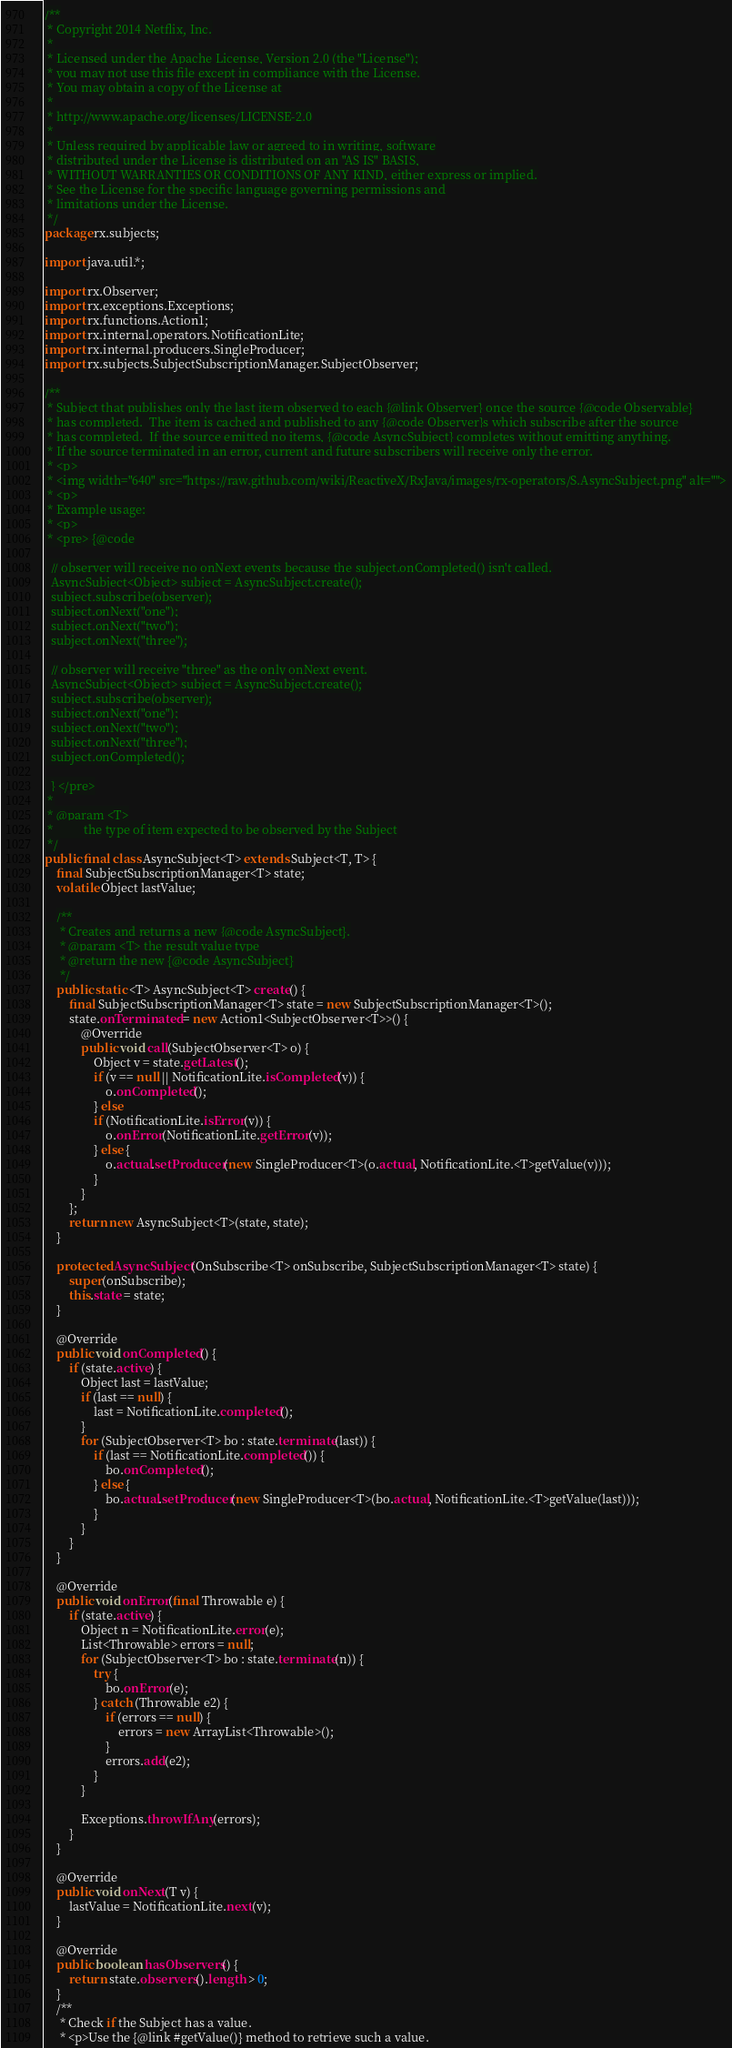<code> <loc_0><loc_0><loc_500><loc_500><_Java_>/**
 * Copyright 2014 Netflix, Inc.
 *
 * Licensed under the Apache License, Version 2.0 (the "License");
 * you may not use this file except in compliance with the License.
 * You may obtain a copy of the License at
 *
 * http://www.apache.org/licenses/LICENSE-2.0
 *
 * Unless required by applicable law or agreed to in writing, software
 * distributed under the License is distributed on an "AS IS" BASIS,
 * WITHOUT WARRANTIES OR CONDITIONS OF ANY KIND, either express or implied.
 * See the License for the specific language governing permissions and
 * limitations under the License.
 */
package rx.subjects;

import java.util.*;

import rx.Observer;
import rx.exceptions.Exceptions;
import rx.functions.Action1;
import rx.internal.operators.NotificationLite;
import rx.internal.producers.SingleProducer;
import rx.subjects.SubjectSubscriptionManager.SubjectObserver;

/**
 * Subject that publishes only the last item observed to each {@link Observer} once the source {@code Observable}
 * has completed.  The item is cached and published to any {@code Observer}s which subscribe after the source
 * has completed.  If the source emitted no items, {@code AsyncSubject} completes without emitting anything.
 * If the source terminated in an error, current and future subscribers will receive only the error.
 * <p>
 * <img width="640" src="https://raw.github.com/wiki/ReactiveX/RxJava/images/rx-operators/S.AsyncSubject.png" alt="">
 * <p>
 * Example usage:
 * <p>
 * <pre> {@code

  // observer will receive no onNext events because the subject.onCompleted() isn't called.
  AsyncSubject<Object> subject = AsyncSubject.create();
  subject.subscribe(observer);
  subject.onNext("one");
  subject.onNext("two");
  subject.onNext("three");

  // observer will receive "three" as the only onNext event.
  AsyncSubject<Object> subject = AsyncSubject.create();
  subject.subscribe(observer);
  subject.onNext("one");
  subject.onNext("two");
  subject.onNext("three");
  subject.onCompleted();

  } </pre>
 *
 * @param <T>
 *          the type of item expected to be observed by the Subject
 */
public final class AsyncSubject<T> extends Subject<T, T> {
    final SubjectSubscriptionManager<T> state;
    volatile Object lastValue;

    /**
     * Creates and returns a new {@code AsyncSubject}.
     * @param <T> the result value type
     * @return the new {@code AsyncSubject}
     */
    public static <T> AsyncSubject<T> create() {
        final SubjectSubscriptionManager<T> state = new SubjectSubscriptionManager<T>();
        state.onTerminated = new Action1<SubjectObserver<T>>() {
            @Override
            public void call(SubjectObserver<T> o) {
                Object v = state.getLatest();
                if (v == null || NotificationLite.isCompleted(v)) {
                    o.onCompleted();
                } else
                if (NotificationLite.isError(v)) {
                    o.onError(NotificationLite.getError(v));
                } else {
                    o.actual.setProducer(new SingleProducer<T>(o.actual, NotificationLite.<T>getValue(v)));
                }
            }
        };
        return new AsyncSubject<T>(state, state);
    }

    protected AsyncSubject(OnSubscribe<T> onSubscribe, SubjectSubscriptionManager<T> state) {
        super(onSubscribe);
        this.state = state;
    }

    @Override
    public void onCompleted() {
        if (state.active) {
            Object last = lastValue;
            if (last == null) {
                last = NotificationLite.completed();
            }
            for (SubjectObserver<T> bo : state.terminate(last)) {
                if (last == NotificationLite.completed()) {
                    bo.onCompleted();
                } else {
                    bo.actual.setProducer(new SingleProducer<T>(bo.actual, NotificationLite.<T>getValue(last)));
                }
            }
        }
    }

    @Override
    public void onError(final Throwable e) {
        if (state.active) {
            Object n = NotificationLite.error(e);
            List<Throwable> errors = null;
            for (SubjectObserver<T> bo : state.terminate(n)) {
                try {
                    bo.onError(e);
                } catch (Throwable e2) {
                    if (errors == null) {
                        errors = new ArrayList<Throwable>();
                    }
                    errors.add(e2);
                }
            }

            Exceptions.throwIfAny(errors);
        }
    }

    @Override
    public void onNext(T v) {
        lastValue = NotificationLite.next(v);
    }

    @Override
    public boolean hasObservers() {
        return state.observers().length > 0;
    }
    /**
     * Check if the Subject has a value.
     * <p>Use the {@link #getValue()} method to retrieve such a value.</code> 